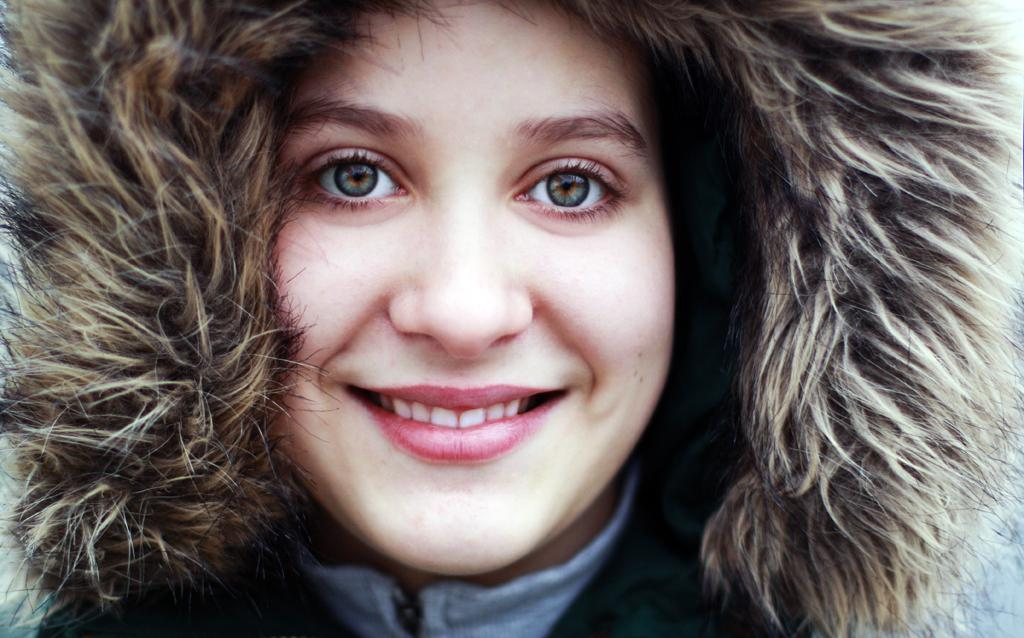Who is present in the image? There is a woman in the picture. What expression does the woman have? The woman is smiling. What type of spoon is the woman holding in the image? There is no spoon present in the image. What feeling does the woman express in the image? The woman expresses happiness through her smile, but we cannot determine her exact feeling from the image. 